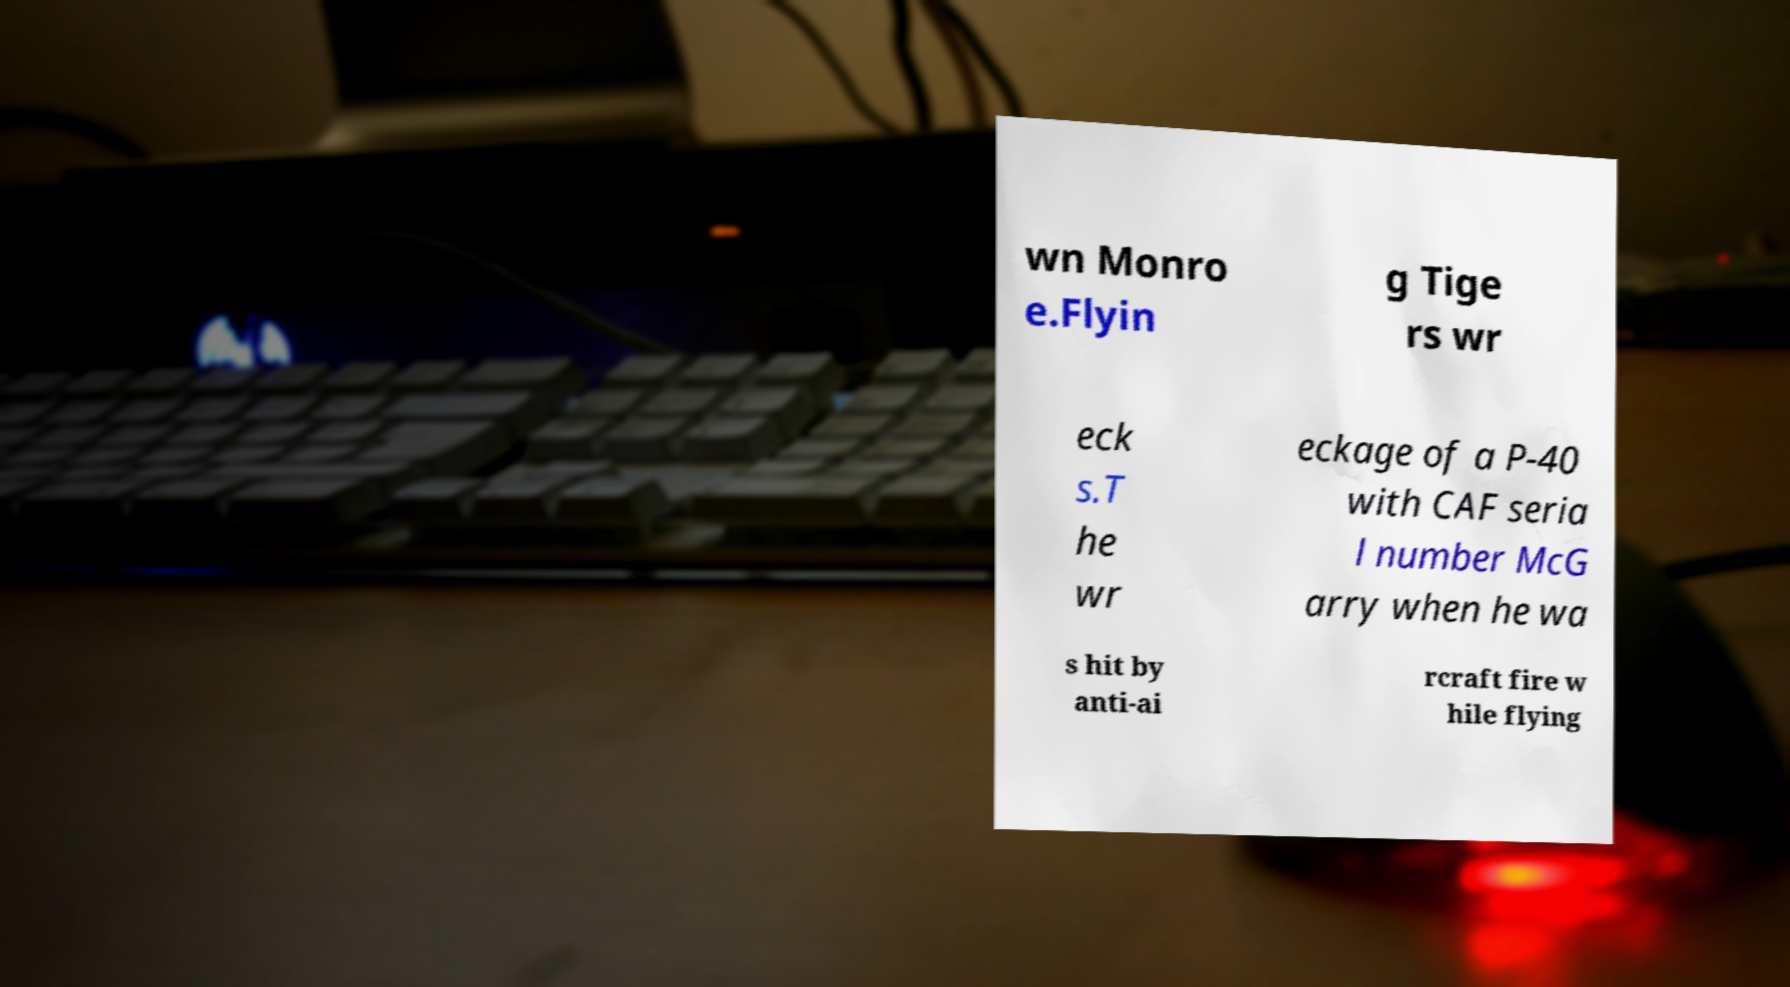There's text embedded in this image that I need extracted. Can you transcribe it verbatim? wn Monro e.Flyin g Tige rs wr eck s.T he wr eckage of a P-40 with CAF seria l number McG arry when he wa s hit by anti-ai rcraft fire w hile flying 